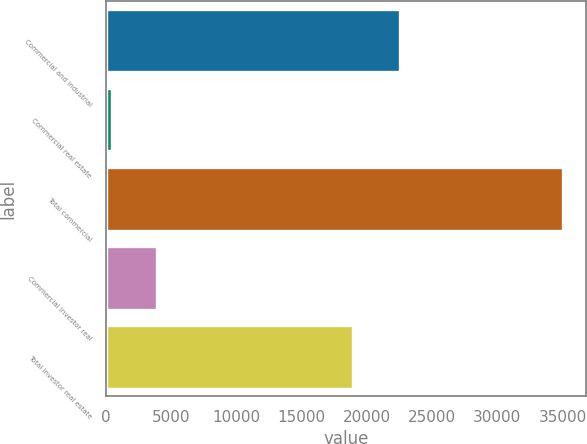Convert chart to OTSL. <chart><loc_0><loc_0><loc_500><loc_500><bar_chart><fcel>Commercial and industrial<fcel>Commercial real estate<fcel>Total commercial<fcel>Commercial investor real<fcel>Total investor real estate<nl><fcel>22540<fcel>470<fcel>35056<fcel>3928.6<fcel>18963.2<nl></chart> 